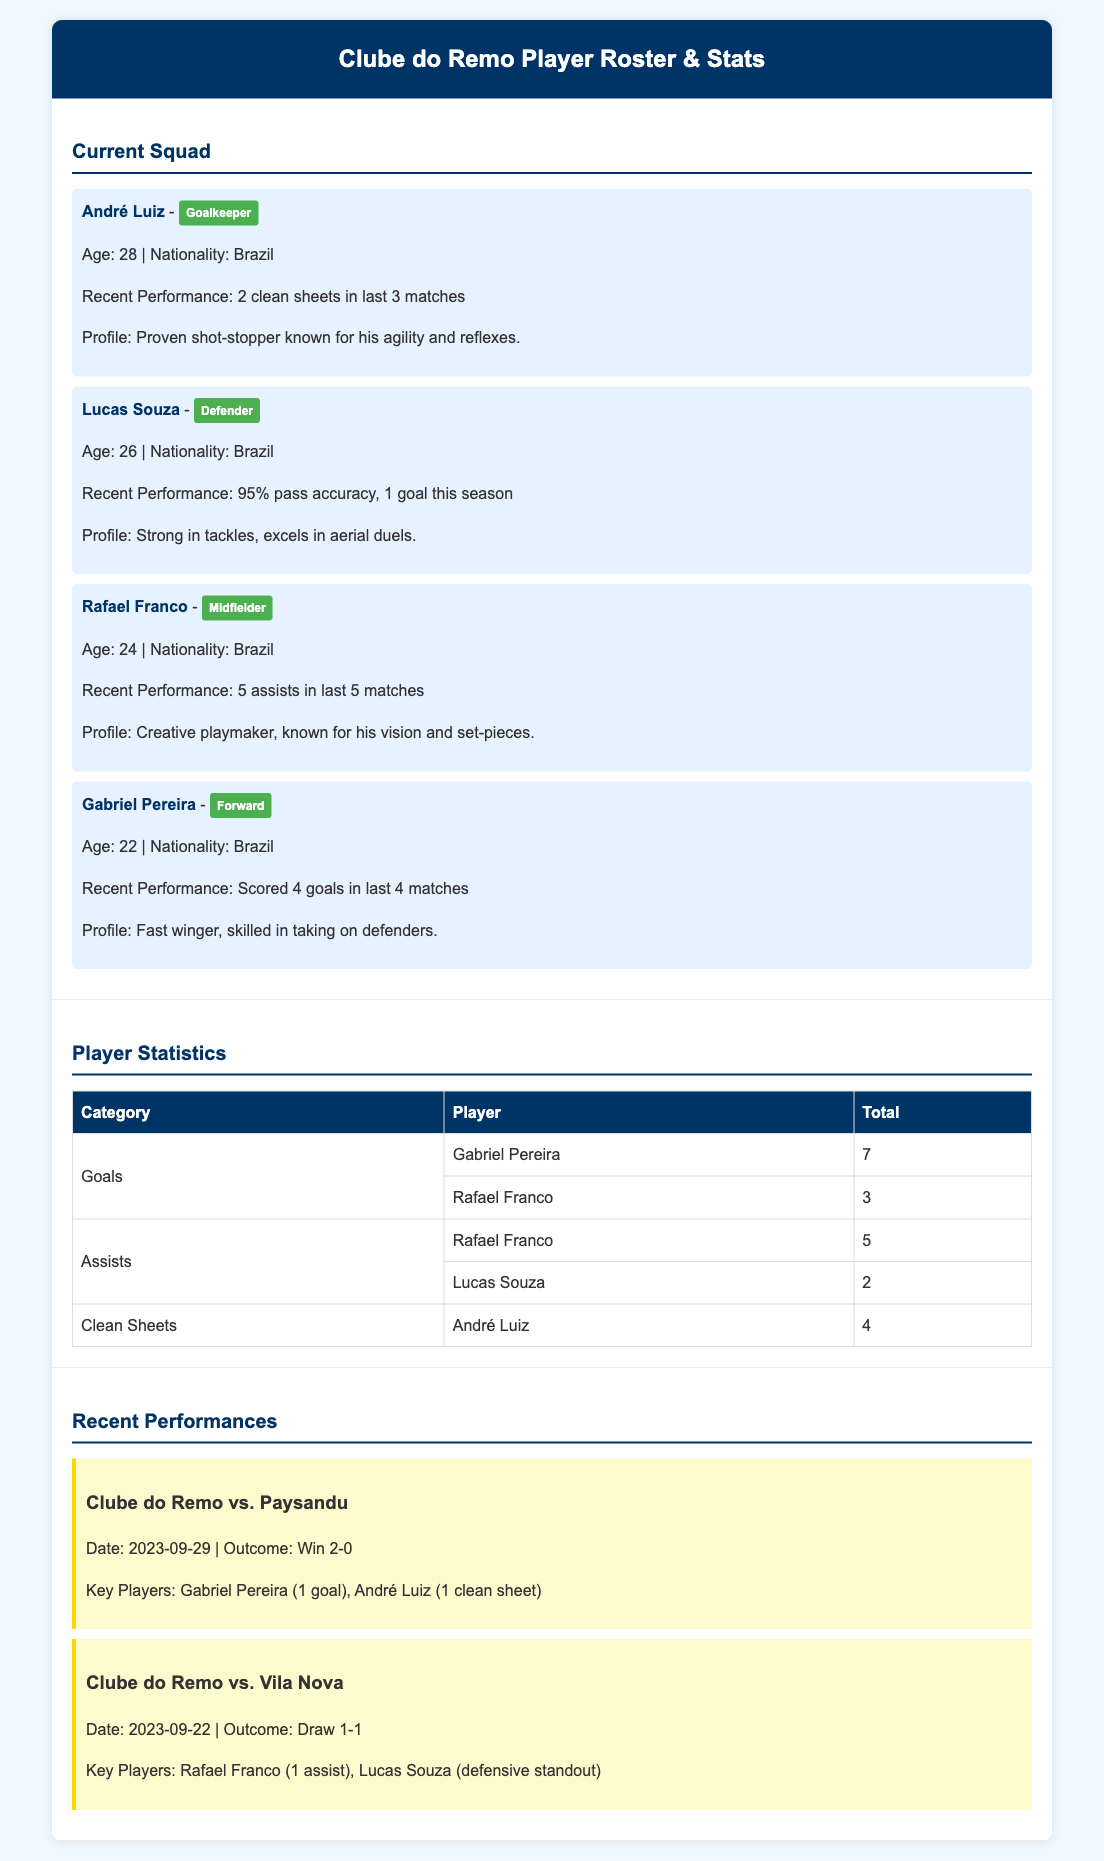What is the age of André Luiz? The document states that André Luiz is 28 years old.
Answer: 28 How many clean sheets does André Luiz have? The player statistics section indicates that André Luiz has 4 clean sheets.
Answer: 4 Who is the midfielder in the current squad? Rafael Franco is identified as the midfielder in the current squad.
Answer: Rafael Franco Which player scored 4 goals in the last 4 matches? The document highlights that Gabriel Pereira scored 4 goals in his last 4 matches.
Answer: Gabriel Pereira What was the outcome of the match against Paysandu? The recent performances section shows that Clube do Remo won the match against Paysandu 2-0.
Answer: Win 2-0 How many assists does Rafael Franco have? The player statistics indicate that Rafael Franco has a total of 5 assists.
Answer: 5 What is Lucas Souza's pass accuracy? The recent performance of Lucas Souza states he has a pass accuracy of 95%.
Answer: 95% Who was the key player in the match against Vila Nova? The document mentions that Rafael Franco was a key player with 1 assist in the match against Vila Nova.
Answer: Rafael Franco What position does Gabriel Pereira play? The document labels Gabriel Pereira as a forward in the current squad.
Answer: Forward 